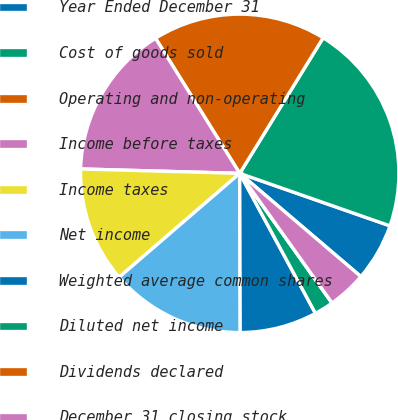<chart> <loc_0><loc_0><loc_500><loc_500><pie_chart><fcel>Year Ended December 31<fcel>Cost of goods sold<fcel>Operating and non-operating<fcel>Income before taxes<fcel>Income taxes<fcel>Net income<fcel>Weighted average common shares<fcel>Diluted net income<fcel>Dividends declared<fcel>December 31 closing stock<nl><fcel>5.88%<fcel>21.57%<fcel>17.65%<fcel>15.69%<fcel>11.76%<fcel>13.73%<fcel>7.84%<fcel>1.96%<fcel>0.0%<fcel>3.92%<nl></chart> 